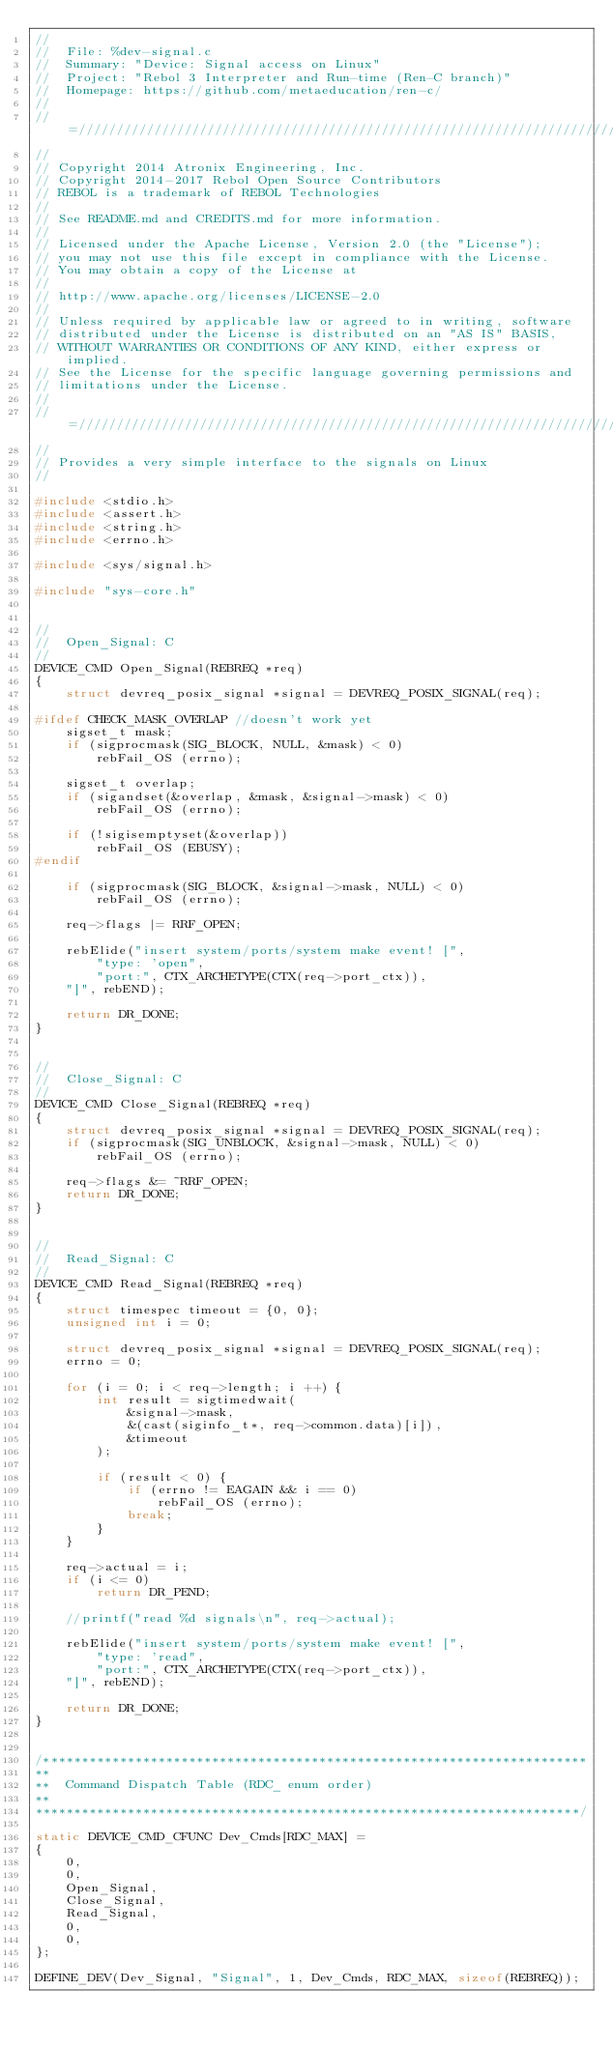Convert code to text. <code><loc_0><loc_0><loc_500><loc_500><_C_>//
//  File: %dev-signal.c
//  Summary: "Device: Signal access on Linux"
//  Project: "Rebol 3 Interpreter and Run-time (Ren-C branch)"
//  Homepage: https://github.com/metaeducation/ren-c/
//
//=////////////////////////////////////////////////////////////////////////=//
//
// Copyright 2014 Atronix Engineering, Inc.
// Copyright 2014-2017 Rebol Open Source Contributors
// REBOL is a trademark of REBOL Technologies
//
// See README.md and CREDITS.md for more information.
//
// Licensed under the Apache License, Version 2.0 (the "License");
// you may not use this file except in compliance with the License.
// You may obtain a copy of the License at
//
// http://www.apache.org/licenses/LICENSE-2.0
//
// Unless required by applicable law or agreed to in writing, software
// distributed under the License is distributed on an "AS IS" BASIS,
// WITHOUT WARRANTIES OR CONDITIONS OF ANY KIND, either express or implied.
// See the License for the specific language governing permissions and
// limitations under the License.
//
//=////////////////////////////////////////////////////////////////////////=//
//
// Provides a very simple interface to the signals on Linux
//

#include <stdio.h>
#include <assert.h>
#include <string.h>
#include <errno.h>

#include <sys/signal.h>

#include "sys-core.h"


//
//  Open_Signal: C
//
DEVICE_CMD Open_Signal(REBREQ *req)
{
    struct devreq_posix_signal *signal = DEVREQ_POSIX_SIGNAL(req);

#ifdef CHECK_MASK_OVERLAP //doesn't work yet
    sigset_t mask;
    if (sigprocmask(SIG_BLOCK, NULL, &mask) < 0)
        rebFail_OS (errno);

    sigset_t overlap;
    if (sigandset(&overlap, &mask, &signal->mask) < 0)
        rebFail_OS (errno);

    if (!sigisemptyset(&overlap))
        rebFail_OS (EBUSY);
#endif

    if (sigprocmask(SIG_BLOCK, &signal->mask, NULL) < 0)
        rebFail_OS (errno);

    req->flags |= RRF_OPEN;

    rebElide("insert system/ports/system make event! [",
        "type: 'open",
        "port:", CTX_ARCHETYPE(CTX(req->port_ctx)),
    "]", rebEND);

    return DR_DONE;
}


//
//  Close_Signal: C
//
DEVICE_CMD Close_Signal(REBREQ *req)
{
    struct devreq_posix_signal *signal = DEVREQ_POSIX_SIGNAL(req);
    if (sigprocmask(SIG_UNBLOCK, &signal->mask, NULL) < 0)
        rebFail_OS (errno);

    req->flags &= ~RRF_OPEN;
    return DR_DONE;
}


//
//  Read_Signal: C
//
DEVICE_CMD Read_Signal(REBREQ *req)
{
    struct timespec timeout = {0, 0};
    unsigned int i = 0;

    struct devreq_posix_signal *signal = DEVREQ_POSIX_SIGNAL(req);
    errno = 0;

    for (i = 0; i < req->length; i ++) {
        int result = sigtimedwait(
            &signal->mask,
            &(cast(siginfo_t*, req->common.data)[i]),
            &timeout
        );

        if (result < 0) {
            if (errno != EAGAIN && i == 0)
                rebFail_OS (errno);
            break;
        }
    }

    req->actual = i;
    if (i <= 0)
        return DR_PEND;

    //printf("read %d signals\n", req->actual);

    rebElide("insert system/ports/system make event! [",
        "type: 'read",
        "port:", CTX_ARCHETYPE(CTX(req->port_ctx)),
    "]", rebEND);

    return DR_DONE;
}


/***********************************************************************
**
**  Command Dispatch Table (RDC_ enum order)
**
***********************************************************************/

static DEVICE_CMD_CFUNC Dev_Cmds[RDC_MAX] =
{
    0,
    0,
    Open_Signal,
    Close_Signal,
    Read_Signal,
    0,
    0,
};

DEFINE_DEV(Dev_Signal, "Signal", 1, Dev_Cmds, RDC_MAX, sizeof(REBREQ));
</code> 